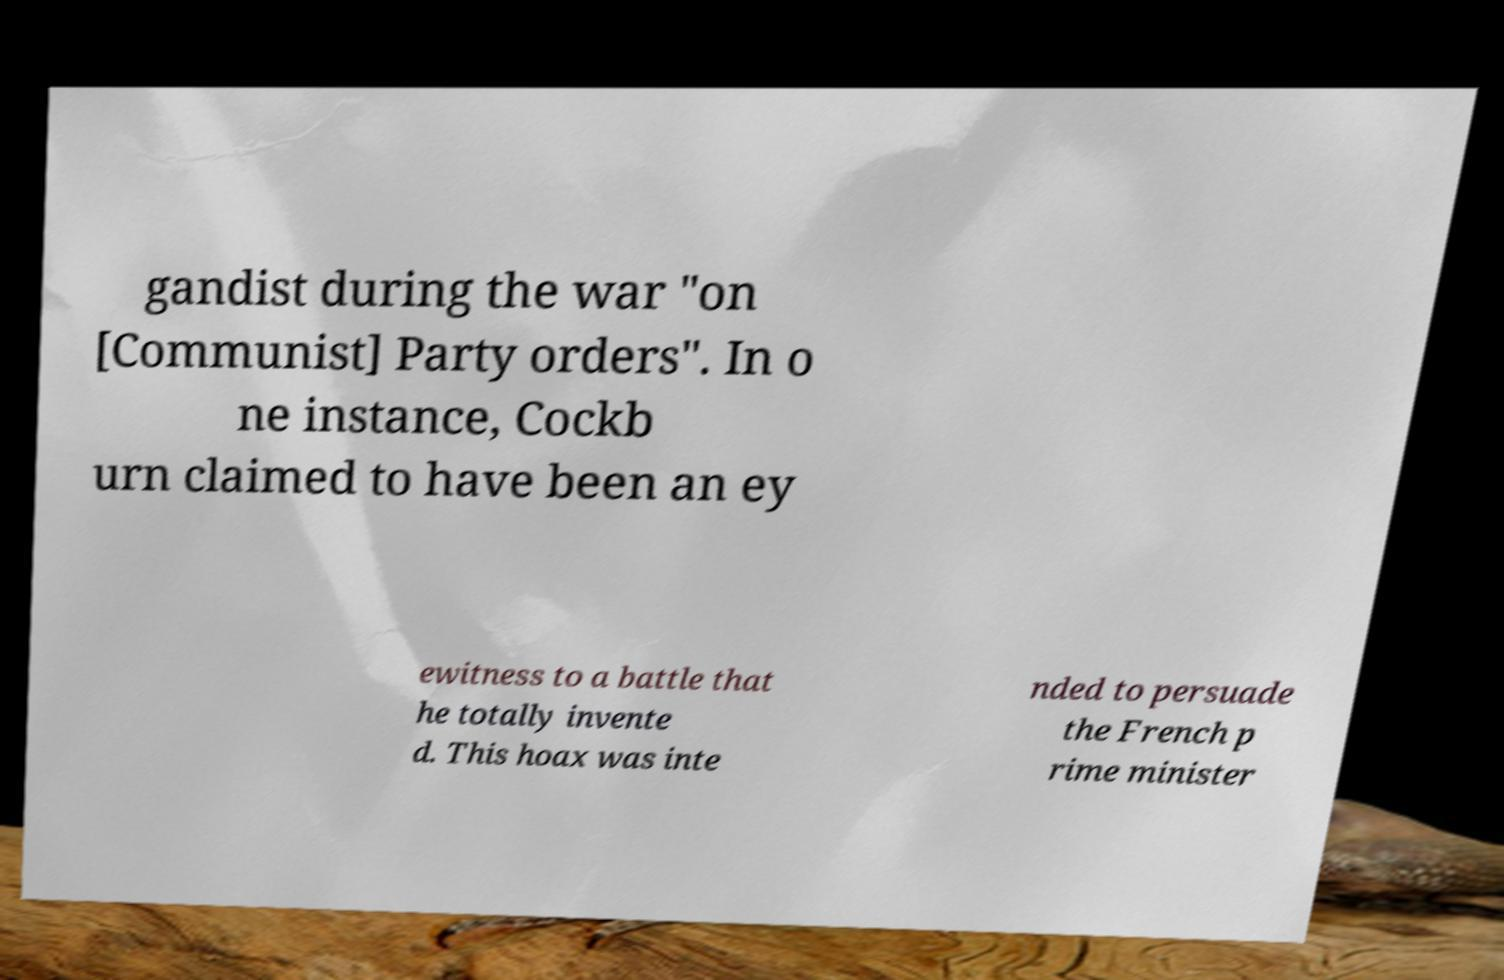I need the written content from this picture converted into text. Can you do that? gandist during the war "on [Communist] Party orders". In o ne instance, Cockb urn claimed to have been an ey ewitness to a battle that he totally invente d. This hoax was inte nded to persuade the French p rime minister 